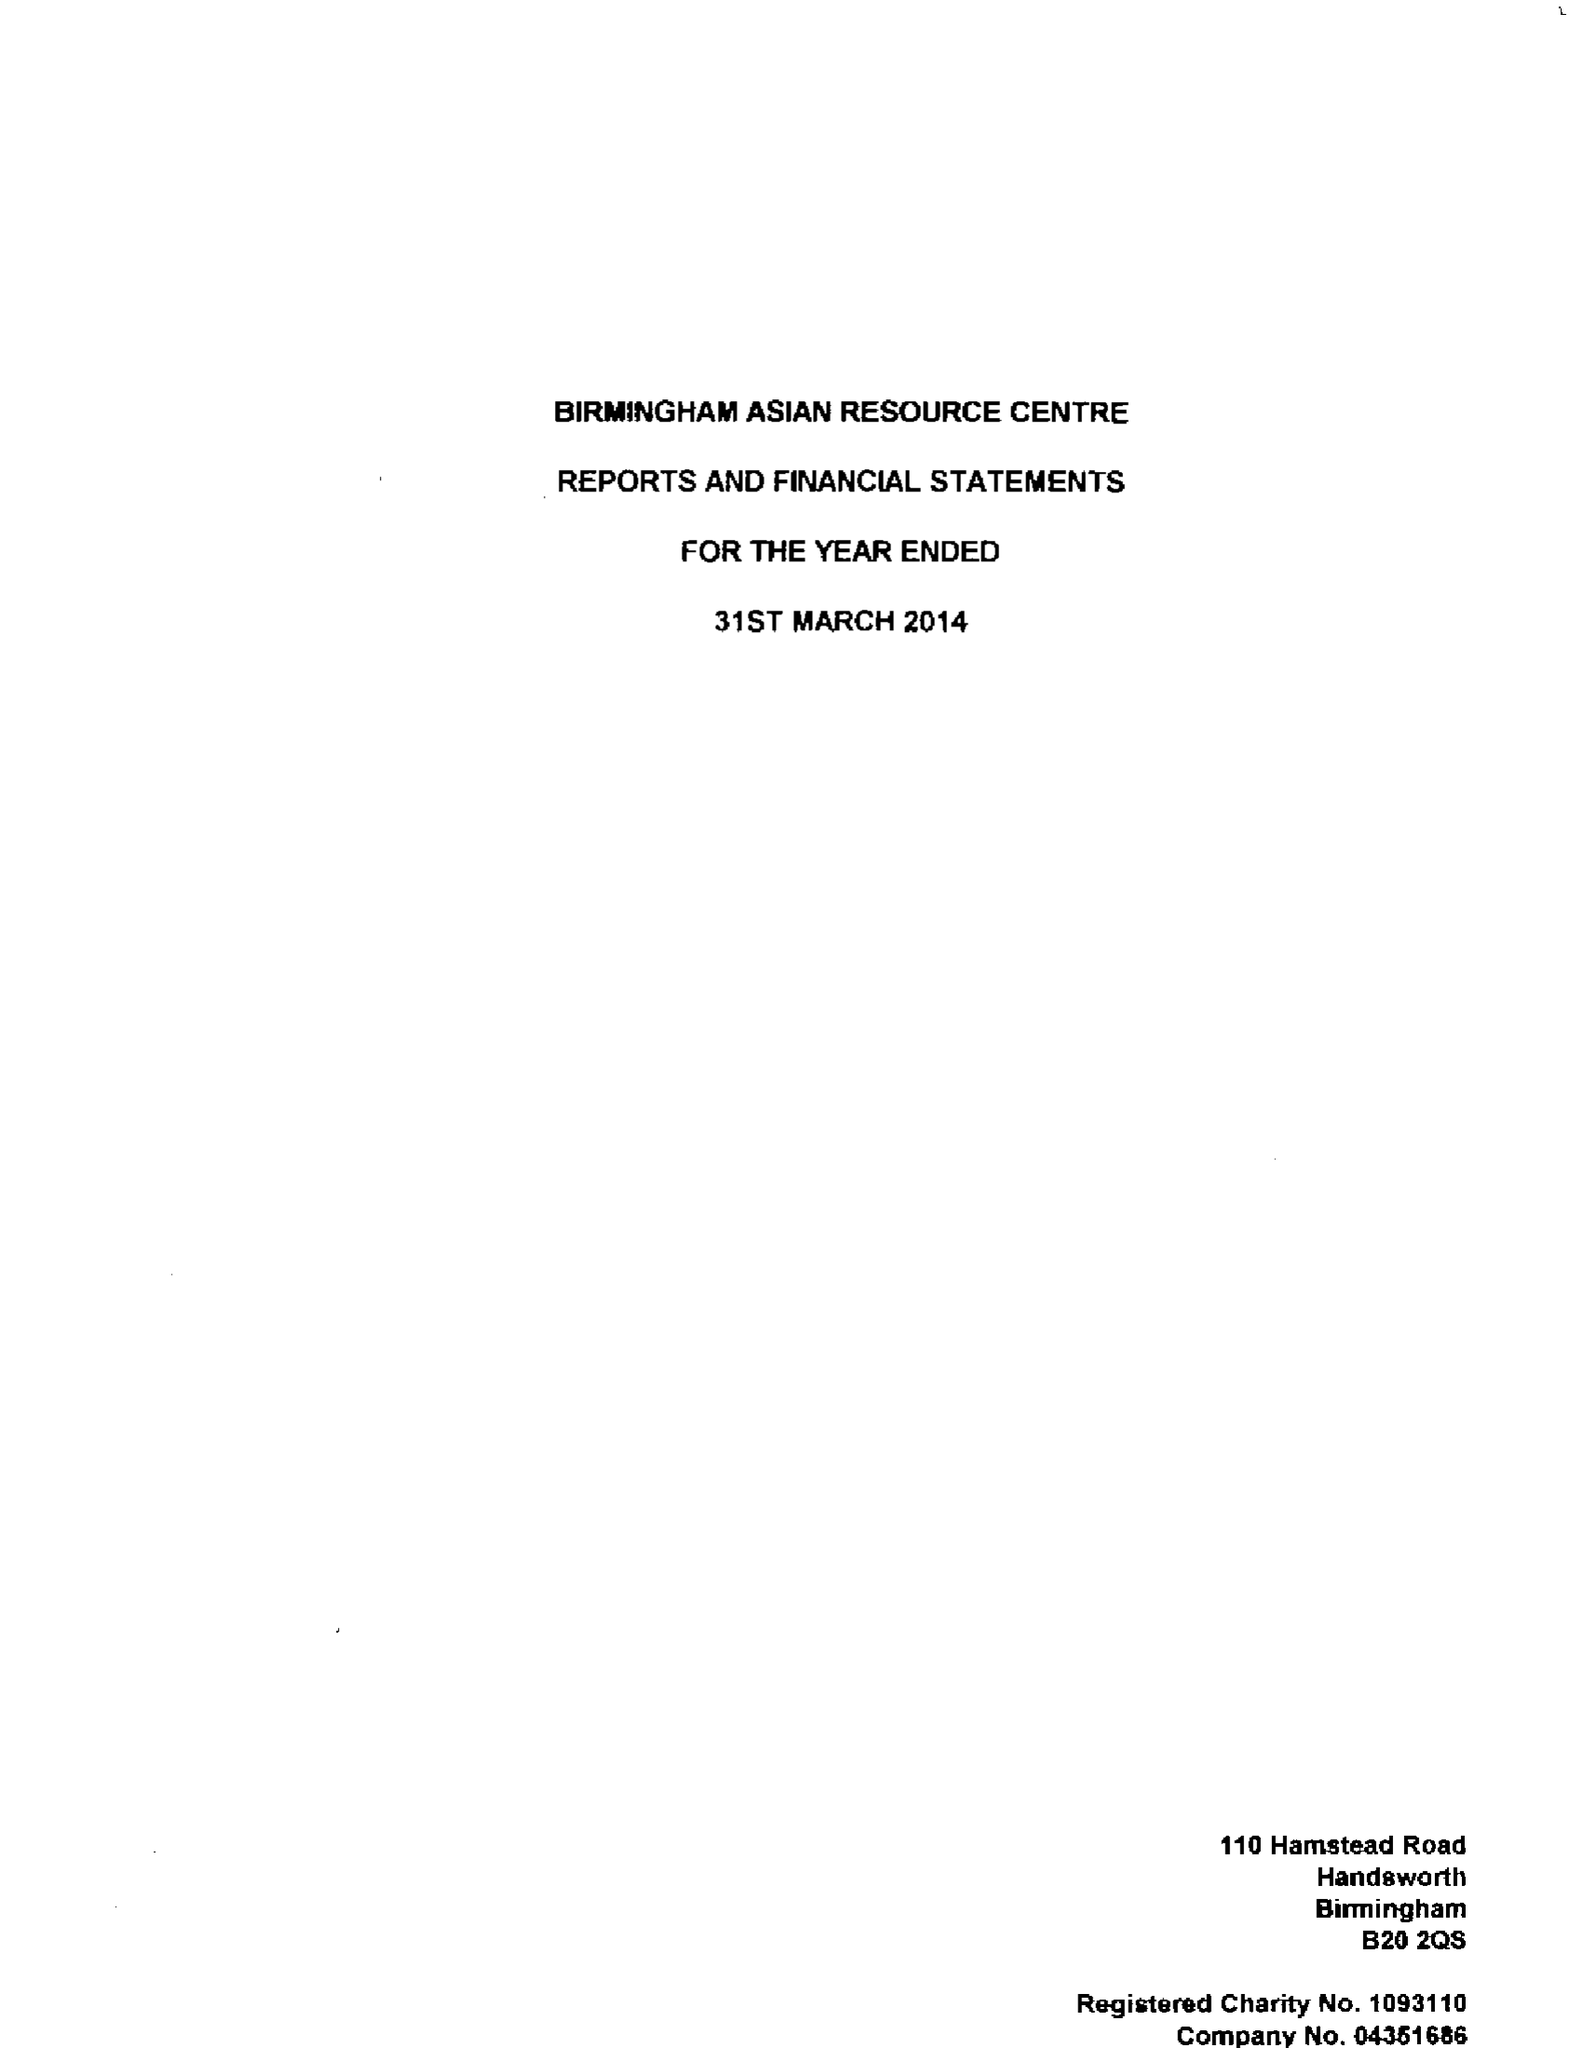What is the value for the address__street_line?
Answer the question using a single word or phrase. 110-114 HAMSTEAD ROAD 